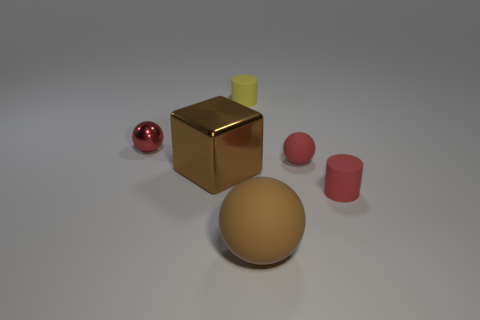There is a red object left of the large object in front of the tiny red cylinder; is there a yellow cylinder that is to the left of it?
Provide a short and direct response. No. What is the size of the matte sphere that is in front of the brown shiny thing?
Keep it short and to the point. Large. What is the material of the thing that is the same size as the brown block?
Provide a succinct answer. Rubber. Is the large matte object the same shape as the yellow matte thing?
Provide a short and direct response. No. How many objects are either small red shiny spheres or tiny red things that are on the right side of the tiny yellow matte cylinder?
Offer a terse response. 3. There is a tiny cylinder that is the same color as the small rubber sphere; what is its material?
Your response must be concise. Rubber. Do the red rubber object in front of the red matte ball and the small red shiny object have the same size?
Your answer should be compact. Yes. What number of yellow rubber objects are in front of the small sphere to the left of the small thing behind the tiny metal ball?
Keep it short and to the point. 0. How many brown objects are metal blocks or small spheres?
Offer a very short reply. 1. There is a big ball that is the same material as the tiny red cylinder; what color is it?
Your answer should be very brief. Brown. 